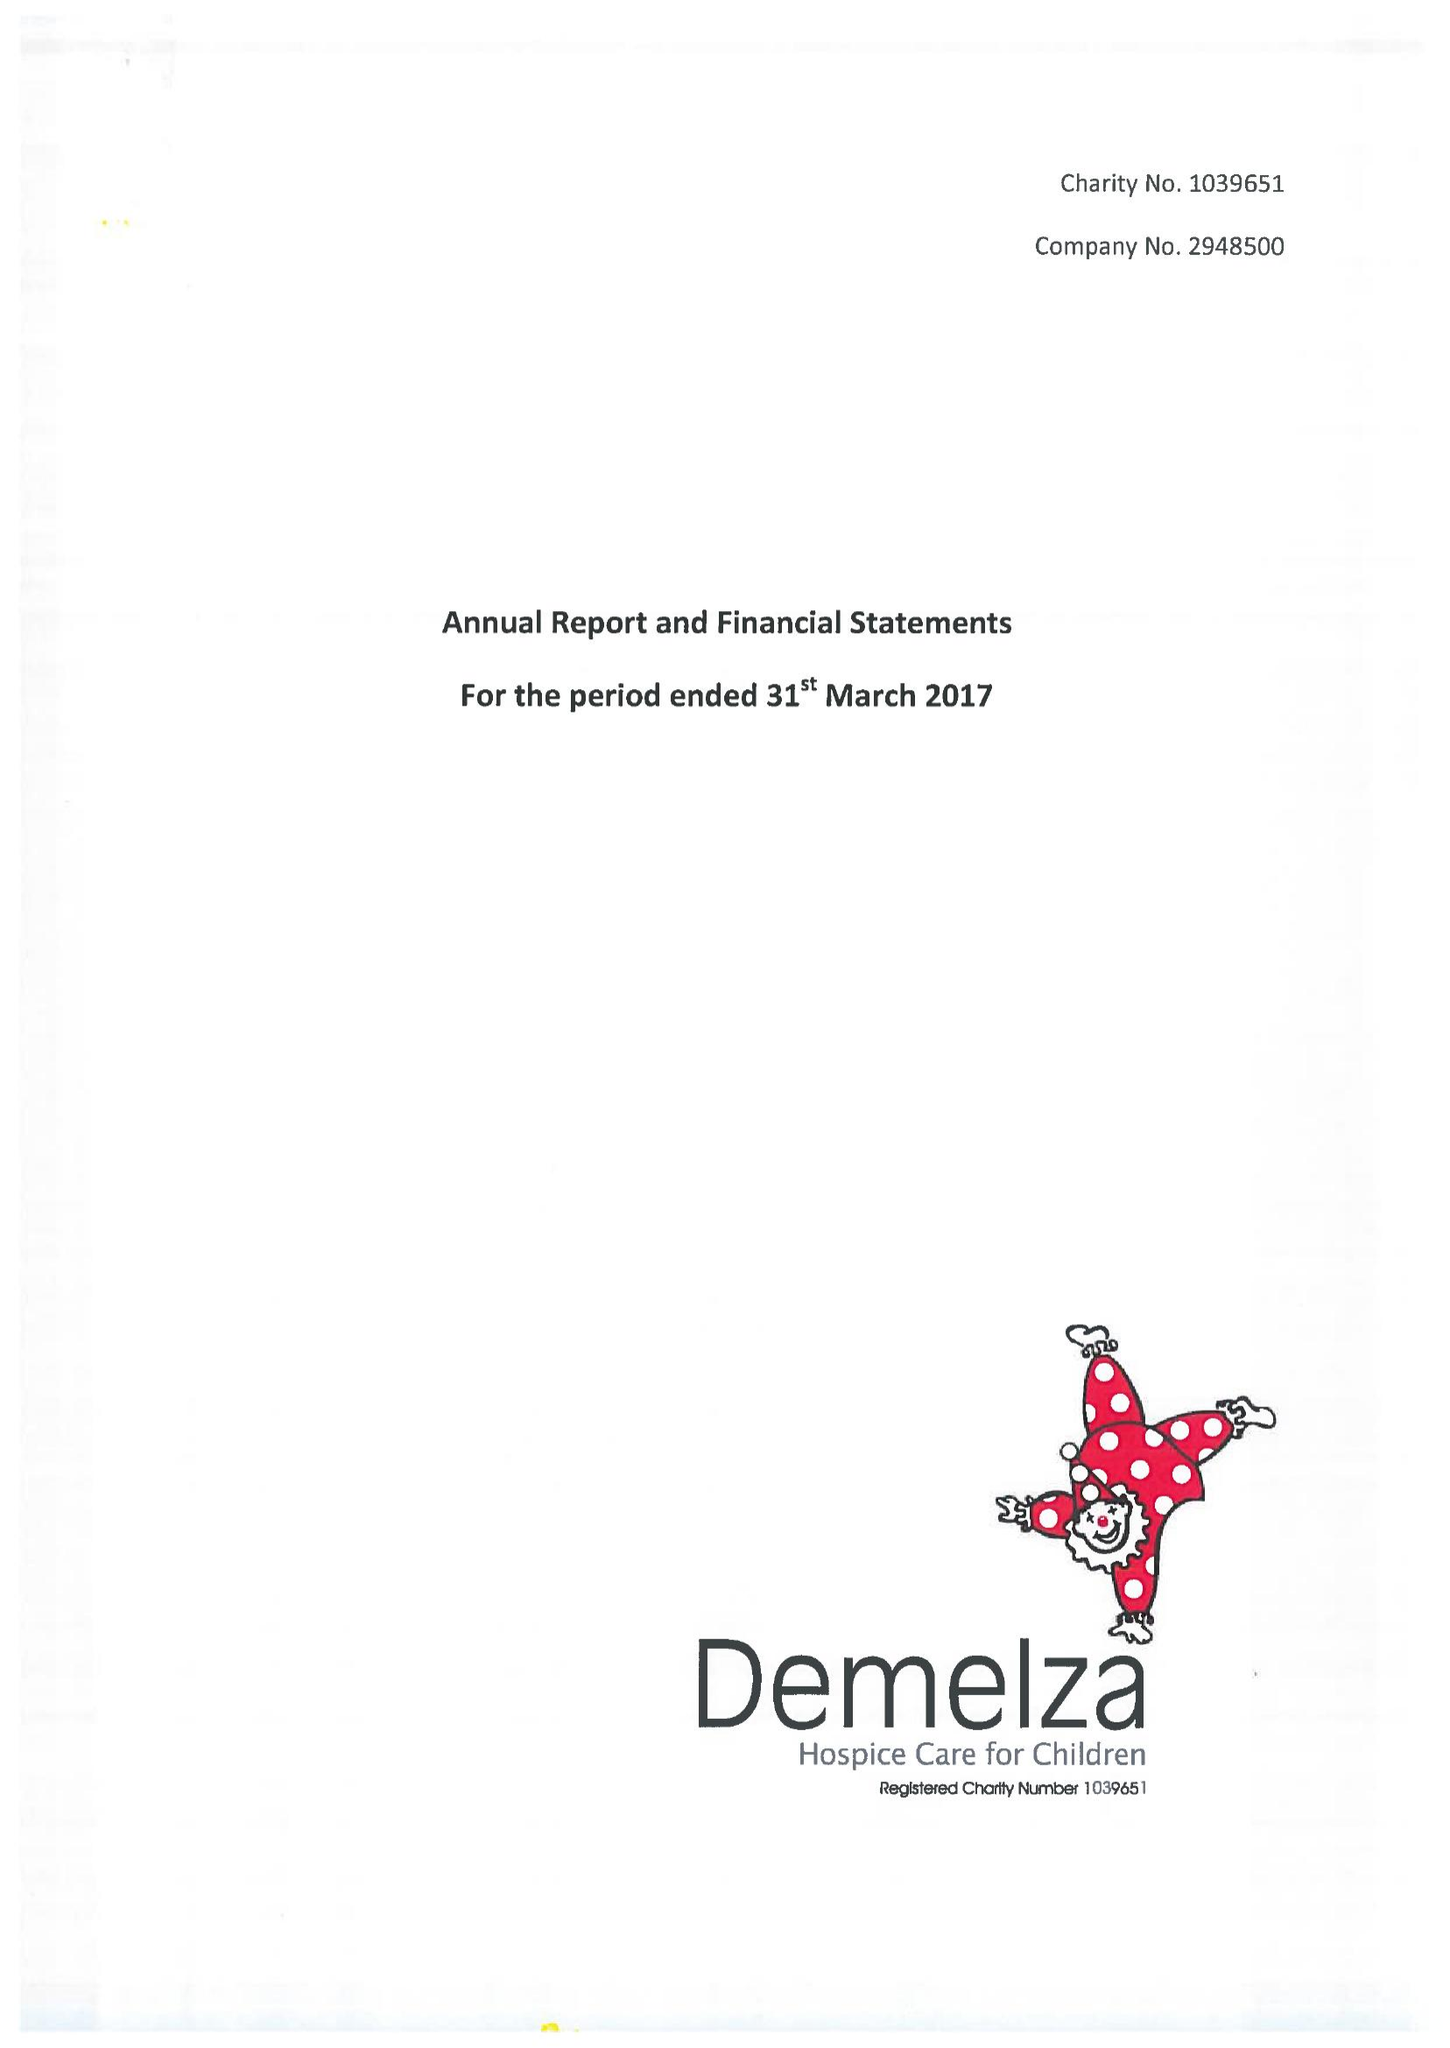What is the value for the charity_number?
Answer the question using a single word or phrase. 1039651 